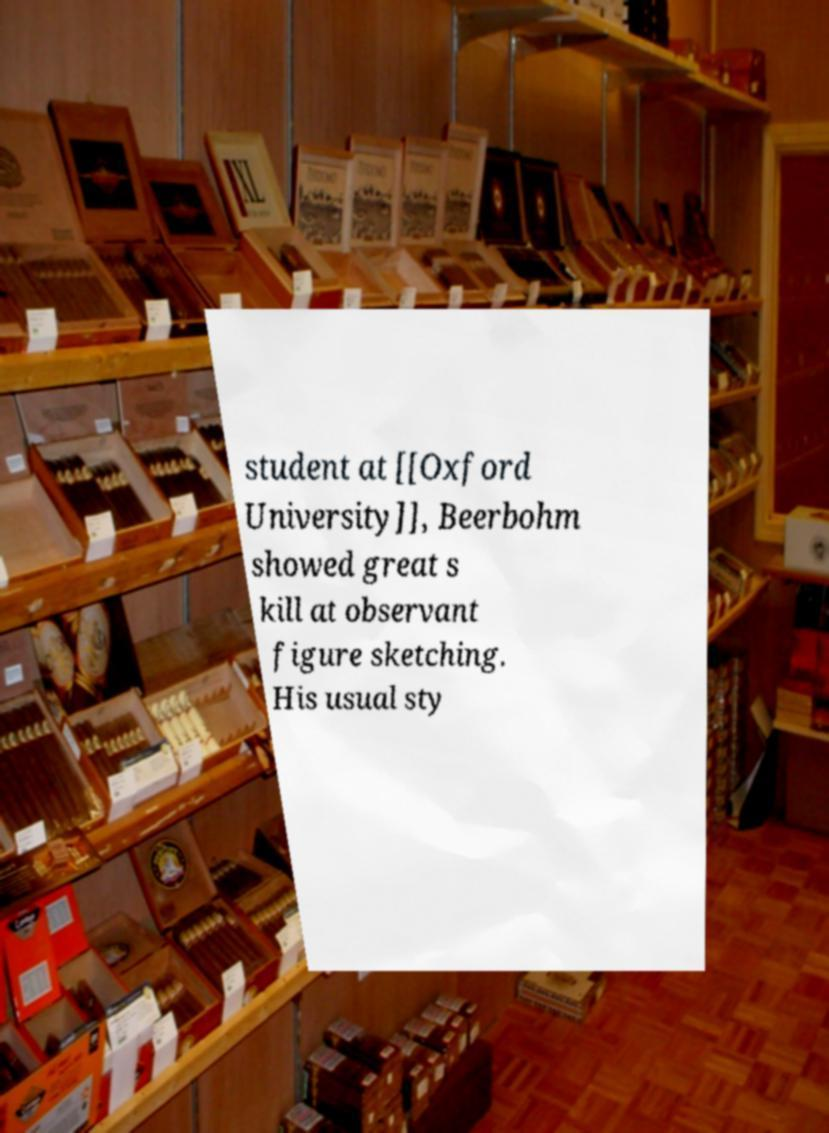Please identify and transcribe the text found in this image. student at [[Oxford University]], Beerbohm showed great s kill at observant figure sketching. His usual sty 